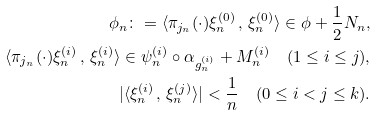<formula> <loc_0><loc_0><loc_500><loc_500>\phi _ { n } \colon = \langle \pi _ { j _ { n } } ( \cdot ) \xi _ { n } ^ { ( 0 ) } \, , \, \xi _ { n } ^ { ( 0 ) } \rangle \in \phi + \frac { 1 } { 2 } N _ { n } , \\ \langle \pi _ { j _ { n } } ( \cdot ) \xi _ { n } ^ { ( i ) } \, , \, \xi _ { n } ^ { ( i ) } \rangle \in \psi _ { n } ^ { ( i ) } \circ \alpha _ { g _ { n } ^ { ( i ) } } + M _ { n } ^ { ( i ) } \quad ( 1 \leq i \leq j ) , \\ | \langle \xi _ { n } ^ { ( i ) } \, , \, \xi _ { n } ^ { ( j ) } \rangle | < \frac { 1 } { n } \quad ( 0 \leq i < j \leq k ) .</formula> 